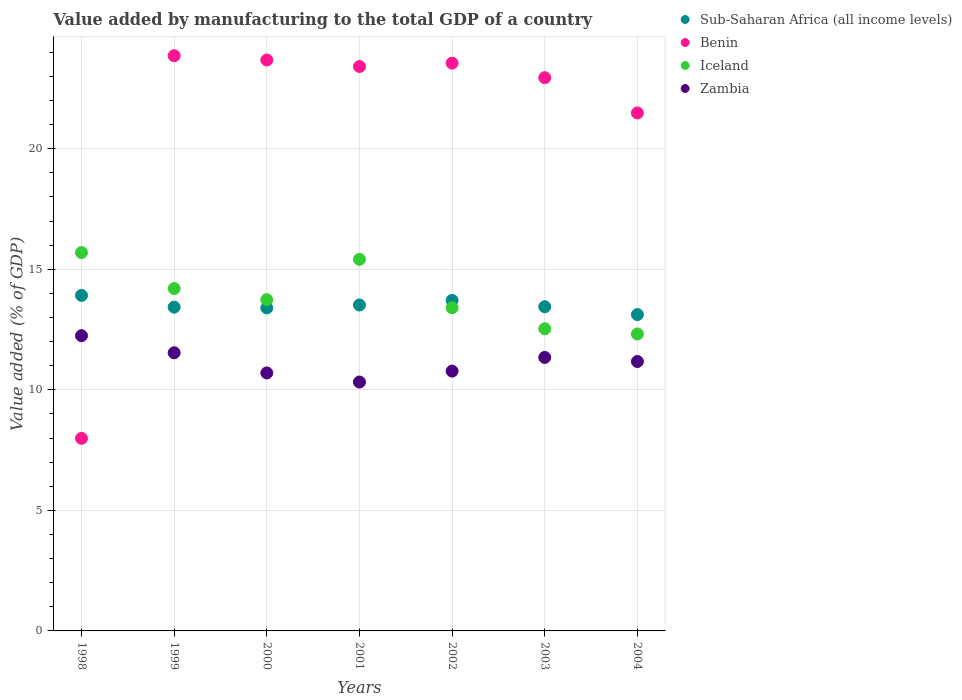Is the number of dotlines equal to the number of legend labels?
Provide a short and direct response. Yes. What is the value added by manufacturing to the total GDP in Zambia in 1998?
Your response must be concise. 12.24. Across all years, what is the maximum value added by manufacturing to the total GDP in Zambia?
Keep it short and to the point. 12.24. Across all years, what is the minimum value added by manufacturing to the total GDP in Sub-Saharan Africa (all income levels)?
Your response must be concise. 13.12. In which year was the value added by manufacturing to the total GDP in Benin maximum?
Your answer should be compact. 1999. In which year was the value added by manufacturing to the total GDP in Benin minimum?
Keep it short and to the point. 1998. What is the total value added by manufacturing to the total GDP in Benin in the graph?
Make the answer very short. 146.9. What is the difference between the value added by manufacturing to the total GDP in Sub-Saharan Africa (all income levels) in 1999 and that in 2003?
Offer a very short reply. -0.02. What is the difference between the value added by manufacturing to the total GDP in Iceland in 2003 and the value added by manufacturing to the total GDP in Zambia in 2001?
Offer a very short reply. 2.21. What is the average value added by manufacturing to the total GDP in Sub-Saharan Africa (all income levels) per year?
Ensure brevity in your answer.  13.5. In the year 2002, what is the difference between the value added by manufacturing to the total GDP in Benin and value added by manufacturing to the total GDP in Iceland?
Your response must be concise. 10.15. What is the ratio of the value added by manufacturing to the total GDP in Zambia in 1998 to that in 2004?
Offer a terse response. 1.1. What is the difference between the highest and the second highest value added by manufacturing to the total GDP in Zambia?
Offer a terse response. 0.71. What is the difference between the highest and the lowest value added by manufacturing to the total GDP in Sub-Saharan Africa (all income levels)?
Your answer should be very brief. 0.8. Is the sum of the value added by manufacturing to the total GDP in Sub-Saharan Africa (all income levels) in 2000 and 2004 greater than the maximum value added by manufacturing to the total GDP in Iceland across all years?
Offer a very short reply. Yes. Is it the case that in every year, the sum of the value added by manufacturing to the total GDP in Zambia and value added by manufacturing to the total GDP in Benin  is greater than the sum of value added by manufacturing to the total GDP in Iceland and value added by manufacturing to the total GDP in Sub-Saharan Africa (all income levels)?
Provide a succinct answer. No. Is it the case that in every year, the sum of the value added by manufacturing to the total GDP in Iceland and value added by manufacturing to the total GDP in Zambia  is greater than the value added by manufacturing to the total GDP in Sub-Saharan Africa (all income levels)?
Offer a terse response. Yes. Does the value added by manufacturing to the total GDP in Benin monotonically increase over the years?
Give a very brief answer. No. How many dotlines are there?
Keep it short and to the point. 4. How many years are there in the graph?
Give a very brief answer. 7. How many legend labels are there?
Ensure brevity in your answer.  4. What is the title of the graph?
Make the answer very short. Value added by manufacturing to the total GDP of a country. What is the label or title of the X-axis?
Make the answer very short. Years. What is the label or title of the Y-axis?
Make the answer very short. Value added (% of GDP). What is the Value added (% of GDP) of Sub-Saharan Africa (all income levels) in 1998?
Ensure brevity in your answer.  13.92. What is the Value added (% of GDP) of Benin in 1998?
Offer a very short reply. 7.99. What is the Value added (% of GDP) of Iceland in 1998?
Provide a succinct answer. 15.69. What is the Value added (% of GDP) of Zambia in 1998?
Keep it short and to the point. 12.24. What is the Value added (% of GDP) in Sub-Saharan Africa (all income levels) in 1999?
Offer a very short reply. 13.43. What is the Value added (% of GDP) of Benin in 1999?
Make the answer very short. 23.86. What is the Value added (% of GDP) of Iceland in 1999?
Make the answer very short. 14.2. What is the Value added (% of GDP) of Zambia in 1999?
Your answer should be compact. 11.54. What is the Value added (% of GDP) of Sub-Saharan Africa (all income levels) in 2000?
Provide a succinct answer. 13.4. What is the Value added (% of GDP) in Benin in 2000?
Offer a terse response. 23.68. What is the Value added (% of GDP) in Iceland in 2000?
Your answer should be compact. 13.74. What is the Value added (% of GDP) in Zambia in 2000?
Keep it short and to the point. 10.7. What is the Value added (% of GDP) in Sub-Saharan Africa (all income levels) in 2001?
Provide a short and direct response. 13.52. What is the Value added (% of GDP) in Benin in 2001?
Provide a succinct answer. 23.41. What is the Value added (% of GDP) in Iceland in 2001?
Your response must be concise. 15.41. What is the Value added (% of GDP) of Zambia in 2001?
Your answer should be compact. 10.32. What is the Value added (% of GDP) in Sub-Saharan Africa (all income levels) in 2002?
Offer a very short reply. 13.71. What is the Value added (% of GDP) of Benin in 2002?
Your answer should be compact. 23.55. What is the Value added (% of GDP) of Iceland in 2002?
Provide a succinct answer. 13.4. What is the Value added (% of GDP) in Zambia in 2002?
Offer a terse response. 10.78. What is the Value added (% of GDP) of Sub-Saharan Africa (all income levels) in 2003?
Provide a short and direct response. 13.45. What is the Value added (% of GDP) of Benin in 2003?
Keep it short and to the point. 22.94. What is the Value added (% of GDP) of Iceland in 2003?
Your answer should be very brief. 12.53. What is the Value added (% of GDP) of Zambia in 2003?
Give a very brief answer. 11.34. What is the Value added (% of GDP) of Sub-Saharan Africa (all income levels) in 2004?
Make the answer very short. 13.12. What is the Value added (% of GDP) of Benin in 2004?
Provide a succinct answer. 21.48. What is the Value added (% of GDP) of Iceland in 2004?
Provide a succinct answer. 12.31. What is the Value added (% of GDP) of Zambia in 2004?
Give a very brief answer. 11.17. Across all years, what is the maximum Value added (% of GDP) of Sub-Saharan Africa (all income levels)?
Offer a very short reply. 13.92. Across all years, what is the maximum Value added (% of GDP) of Benin?
Your answer should be very brief. 23.86. Across all years, what is the maximum Value added (% of GDP) in Iceland?
Your answer should be very brief. 15.69. Across all years, what is the maximum Value added (% of GDP) in Zambia?
Make the answer very short. 12.24. Across all years, what is the minimum Value added (% of GDP) in Sub-Saharan Africa (all income levels)?
Ensure brevity in your answer.  13.12. Across all years, what is the minimum Value added (% of GDP) of Benin?
Give a very brief answer. 7.99. Across all years, what is the minimum Value added (% of GDP) in Iceland?
Give a very brief answer. 12.31. Across all years, what is the minimum Value added (% of GDP) of Zambia?
Your answer should be very brief. 10.32. What is the total Value added (% of GDP) of Sub-Saharan Africa (all income levels) in the graph?
Your answer should be very brief. 94.53. What is the total Value added (% of GDP) of Benin in the graph?
Offer a terse response. 146.9. What is the total Value added (% of GDP) in Iceland in the graph?
Your answer should be compact. 97.29. What is the total Value added (% of GDP) in Zambia in the graph?
Provide a succinct answer. 78.09. What is the difference between the Value added (% of GDP) in Sub-Saharan Africa (all income levels) in 1998 and that in 1999?
Your answer should be very brief. 0.49. What is the difference between the Value added (% of GDP) in Benin in 1998 and that in 1999?
Your response must be concise. -15.87. What is the difference between the Value added (% of GDP) of Iceland in 1998 and that in 1999?
Offer a very short reply. 1.49. What is the difference between the Value added (% of GDP) of Zambia in 1998 and that in 1999?
Offer a terse response. 0.71. What is the difference between the Value added (% of GDP) of Sub-Saharan Africa (all income levels) in 1998 and that in 2000?
Provide a short and direct response. 0.52. What is the difference between the Value added (% of GDP) of Benin in 1998 and that in 2000?
Keep it short and to the point. -15.69. What is the difference between the Value added (% of GDP) in Iceland in 1998 and that in 2000?
Give a very brief answer. 1.95. What is the difference between the Value added (% of GDP) in Zambia in 1998 and that in 2000?
Your answer should be compact. 1.54. What is the difference between the Value added (% of GDP) of Sub-Saharan Africa (all income levels) in 1998 and that in 2001?
Make the answer very short. 0.4. What is the difference between the Value added (% of GDP) in Benin in 1998 and that in 2001?
Your answer should be very brief. -15.42. What is the difference between the Value added (% of GDP) of Iceland in 1998 and that in 2001?
Offer a very short reply. 0.28. What is the difference between the Value added (% of GDP) of Zambia in 1998 and that in 2001?
Keep it short and to the point. 1.92. What is the difference between the Value added (% of GDP) of Sub-Saharan Africa (all income levels) in 1998 and that in 2002?
Provide a succinct answer. 0.21. What is the difference between the Value added (% of GDP) in Benin in 1998 and that in 2002?
Provide a short and direct response. -15.56. What is the difference between the Value added (% of GDP) of Iceland in 1998 and that in 2002?
Ensure brevity in your answer.  2.29. What is the difference between the Value added (% of GDP) of Zambia in 1998 and that in 2002?
Provide a short and direct response. 1.47. What is the difference between the Value added (% of GDP) of Sub-Saharan Africa (all income levels) in 1998 and that in 2003?
Give a very brief answer. 0.47. What is the difference between the Value added (% of GDP) of Benin in 1998 and that in 2003?
Ensure brevity in your answer.  -14.96. What is the difference between the Value added (% of GDP) of Iceland in 1998 and that in 2003?
Give a very brief answer. 3.16. What is the difference between the Value added (% of GDP) in Zambia in 1998 and that in 2003?
Make the answer very short. 0.9. What is the difference between the Value added (% of GDP) in Sub-Saharan Africa (all income levels) in 1998 and that in 2004?
Offer a very short reply. 0.8. What is the difference between the Value added (% of GDP) of Benin in 1998 and that in 2004?
Provide a succinct answer. -13.5. What is the difference between the Value added (% of GDP) in Iceland in 1998 and that in 2004?
Offer a terse response. 3.38. What is the difference between the Value added (% of GDP) in Zambia in 1998 and that in 2004?
Offer a terse response. 1.07. What is the difference between the Value added (% of GDP) of Sub-Saharan Africa (all income levels) in 1999 and that in 2000?
Provide a succinct answer. 0.03. What is the difference between the Value added (% of GDP) in Benin in 1999 and that in 2000?
Make the answer very short. 0.18. What is the difference between the Value added (% of GDP) in Iceland in 1999 and that in 2000?
Ensure brevity in your answer.  0.46. What is the difference between the Value added (% of GDP) of Zambia in 1999 and that in 2000?
Ensure brevity in your answer.  0.84. What is the difference between the Value added (% of GDP) of Sub-Saharan Africa (all income levels) in 1999 and that in 2001?
Give a very brief answer. -0.09. What is the difference between the Value added (% of GDP) of Benin in 1999 and that in 2001?
Offer a very short reply. 0.45. What is the difference between the Value added (% of GDP) in Iceland in 1999 and that in 2001?
Offer a terse response. -1.21. What is the difference between the Value added (% of GDP) of Zambia in 1999 and that in 2001?
Offer a terse response. 1.21. What is the difference between the Value added (% of GDP) in Sub-Saharan Africa (all income levels) in 1999 and that in 2002?
Ensure brevity in your answer.  -0.28. What is the difference between the Value added (% of GDP) in Benin in 1999 and that in 2002?
Your answer should be compact. 0.31. What is the difference between the Value added (% of GDP) of Iceland in 1999 and that in 2002?
Your answer should be compact. 0.8. What is the difference between the Value added (% of GDP) of Zambia in 1999 and that in 2002?
Your response must be concise. 0.76. What is the difference between the Value added (% of GDP) of Sub-Saharan Africa (all income levels) in 1999 and that in 2003?
Offer a very short reply. -0.02. What is the difference between the Value added (% of GDP) of Benin in 1999 and that in 2003?
Keep it short and to the point. 0.91. What is the difference between the Value added (% of GDP) of Iceland in 1999 and that in 2003?
Your answer should be very brief. 1.67. What is the difference between the Value added (% of GDP) in Zambia in 1999 and that in 2003?
Keep it short and to the point. 0.19. What is the difference between the Value added (% of GDP) of Sub-Saharan Africa (all income levels) in 1999 and that in 2004?
Offer a terse response. 0.31. What is the difference between the Value added (% of GDP) of Benin in 1999 and that in 2004?
Your response must be concise. 2.37. What is the difference between the Value added (% of GDP) in Iceland in 1999 and that in 2004?
Offer a terse response. 1.88. What is the difference between the Value added (% of GDP) of Zambia in 1999 and that in 2004?
Offer a terse response. 0.36. What is the difference between the Value added (% of GDP) in Sub-Saharan Africa (all income levels) in 2000 and that in 2001?
Offer a very short reply. -0.12. What is the difference between the Value added (% of GDP) of Benin in 2000 and that in 2001?
Offer a very short reply. 0.27. What is the difference between the Value added (% of GDP) of Iceland in 2000 and that in 2001?
Offer a very short reply. -1.67. What is the difference between the Value added (% of GDP) of Zambia in 2000 and that in 2001?
Provide a short and direct response. 0.38. What is the difference between the Value added (% of GDP) of Sub-Saharan Africa (all income levels) in 2000 and that in 2002?
Keep it short and to the point. -0.31. What is the difference between the Value added (% of GDP) in Benin in 2000 and that in 2002?
Your response must be concise. 0.13. What is the difference between the Value added (% of GDP) in Iceland in 2000 and that in 2002?
Ensure brevity in your answer.  0.34. What is the difference between the Value added (% of GDP) in Zambia in 2000 and that in 2002?
Provide a short and direct response. -0.08. What is the difference between the Value added (% of GDP) of Sub-Saharan Africa (all income levels) in 2000 and that in 2003?
Provide a succinct answer. -0.05. What is the difference between the Value added (% of GDP) of Benin in 2000 and that in 2003?
Offer a terse response. 0.73. What is the difference between the Value added (% of GDP) of Iceland in 2000 and that in 2003?
Keep it short and to the point. 1.21. What is the difference between the Value added (% of GDP) of Zambia in 2000 and that in 2003?
Your response must be concise. -0.64. What is the difference between the Value added (% of GDP) of Sub-Saharan Africa (all income levels) in 2000 and that in 2004?
Ensure brevity in your answer.  0.28. What is the difference between the Value added (% of GDP) in Benin in 2000 and that in 2004?
Offer a terse response. 2.19. What is the difference between the Value added (% of GDP) in Iceland in 2000 and that in 2004?
Keep it short and to the point. 1.42. What is the difference between the Value added (% of GDP) in Zambia in 2000 and that in 2004?
Keep it short and to the point. -0.47. What is the difference between the Value added (% of GDP) of Sub-Saharan Africa (all income levels) in 2001 and that in 2002?
Your answer should be compact. -0.19. What is the difference between the Value added (% of GDP) in Benin in 2001 and that in 2002?
Offer a terse response. -0.14. What is the difference between the Value added (% of GDP) of Iceland in 2001 and that in 2002?
Your answer should be very brief. 2.01. What is the difference between the Value added (% of GDP) of Zambia in 2001 and that in 2002?
Provide a short and direct response. -0.45. What is the difference between the Value added (% of GDP) in Sub-Saharan Africa (all income levels) in 2001 and that in 2003?
Provide a succinct answer. 0.07. What is the difference between the Value added (% of GDP) in Benin in 2001 and that in 2003?
Offer a terse response. 0.46. What is the difference between the Value added (% of GDP) in Iceland in 2001 and that in 2003?
Your answer should be very brief. 2.88. What is the difference between the Value added (% of GDP) in Zambia in 2001 and that in 2003?
Keep it short and to the point. -1.02. What is the difference between the Value added (% of GDP) of Sub-Saharan Africa (all income levels) in 2001 and that in 2004?
Make the answer very short. 0.4. What is the difference between the Value added (% of GDP) of Benin in 2001 and that in 2004?
Your answer should be very brief. 1.92. What is the difference between the Value added (% of GDP) in Iceland in 2001 and that in 2004?
Your answer should be compact. 3.1. What is the difference between the Value added (% of GDP) of Zambia in 2001 and that in 2004?
Provide a succinct answer. -0.85. What is the difference between the Value added (% of GDP) in Sub-Saharan Africa (all income levels) in 2002 and that in 2003?
Offer a very short reply. 0.26. What is the difference between the Value added (% of GDP) in Benin in 2002 and that in 2003?
Your answer should be compact. 0.6. What is the difference between the Value added (% of GDP) in Iceland in 2002 and that in 2003?
Provide a succinct answer. 0.87. What is the difference between the Value added (% of GDP) in Zambia in 2002 and that in 2003?
Make the answer very short. -0.57. What is the difference between the Value added (% of GDP) in Sub-Saharan Africa (all income levels) in 2002 and that in 2004?
Keep it short and to the point. 0.59. What is the difference between the Value added (% of GDP) in Benin in 2002 and that in 2004?
Your answer should be very brief. 2.06. What is the difference between the Value added (% of GDP) of Iceland in 2002 and that in 2004?
Give a very brief answer. 1.09. What is the difference between the Value added (% of GDP) of Zambia in 2002 and that in 2004?
Ensure brevity in your answer.  -0.4. What is the difference between the Value added (% of GDP) in Sub-Saharan Africa (all income levels) in 2003 and that in 2004?
Keep it short and to the point. 0.33. What is the difference between the Value added (% of GDP) in Benin in 2003 and that in 2004?
Make the answer very short. 1.46. What is the difference between the Value added (% of GDP) in Iceland in 2003 and that in 2004?
Provide a succinct answer. 0.22. What is the difference between the Value added (% of GDP) of Zambia in 2003 and that in 2004?
Provide a succinct answer. 0.17. What is the difference between the Value added (% of GDP) of Sub-Saharan Africa (all income levels) in 1998 and the Value added (% of GDP) of Benin in 1999?
Provide a short and direct response. -9.94. What is the difference between the Value added (% of GDP) of Sub-Saharan Africa (all income levels) in 1998 and the Value added (% of GDP) of Iceland in 1999?
Keep it short and to the point. -0.28. What is the difference between the Value added (% of GDP) in Sub-Saharan Africa (all income levels) in 1998 and the Value added (% of GDP) in Zambia in 1999?
Your response must be concise. 2.38. What is the difference between the Value added (% of GDP) of Benin in 1998 and the Value added (% of GDP) of Iceland in 1999?
Provide a short and direct response. -6.21. What is the difference between the Value added (% of GDP) of Benin in 1998 and the Value added (% of GDP) of Zambia in 1999?
Provide a short and direct response. -3.55. What is the difference between the Value added (% of GDP) in Iceland in 1998 and the Value added (% of GDP) in Zambia in 1999?
Offer a very short reply. 4.15. What is the difference between the Value added (% of GDP) of Sub-Saharan Africa (all income levels) in 1998 and the Value added (% of GDP) of Benin in 2000?
Your answer should be very brief. -9.76. What is the difference between the Value added (% of GDP) in Sub-Saharan Africa (all income levels) in 1998 and the Value added (% of GDP) in Iceland in 2000?
Provide a succinct answer. 0.18. What is the difference between the Value added (% of GDP) of Sub-Saharan Africa (all income levels) in 1998 and the Value added (% of GDP) of Zambia in 2000?
Offer a very short reply. 3.22. What is the difference between the Value added (% of GDP) of Benin in 1998 and the Value added (% of GDP) of Iceland in 2000?
Your response must be concise. -5.75. What is the difference between the Value added (% of GDP) in Benin in 1998 and the Value added (% of GDP) in Zambia in 2000?
Ensure brevity in your answer.  -2.71. What is the difference between the Value added (% of GDP) of Iceland in 1998 and the Value added (% of GDP) of Zambia in 2000?
Make the answer very short. 4.99. What is the difference between the Value added (% of GDP) of Sub-Saharan Africa (all income levels) in 1998 and the Value added (% of GDP) of Benin in 2001?
Offer a terse response. -9.49. What is the difference between the Value added (% of GDP) of Sub-Saharan Africa (all income levels) in 1998 and the Value added (% of GDP) of Iceland in 2001?
Ensure brevity in your answer.  -1.5. What is the difference between the Value added (% of GDP) in Sub-Saharan Africa (all income levels) in 1998 and the Value added (% of GDP) in Zambia in 2001?
Give a very brief answer. 3.59. What is the difference between the Value added (% of GDP) of Benin in 1998 and the Value added (% of GDP) of Iceland in 2001?
Ensure brevity in your answer.  -7.42. What is the difference between the Value added (% of GDP) of Benin in 1998 and the Value added (% of GDP) of Zambia in 2001?
Make the answer very short. -2.33. What is the difference between the Value added (% of GDP) of Iceland in 1998 and the Value added (% of GDP) of Zambia in 2001?
Your answer should be very brief. 5.37. What is the difference between the Value added (% of GDP) in Sub-Saharan Africa (all income levels) in 1998 and the Value added (% of GDP) in Benin in 2002?
Provide a short and direct response. -9.63. What is the difference between the Value added (% of GDP) in Sub-Saharan Africa (all income levels) in 1998 and the Value added (% of GDP) in Iceland in 2002?
Give a very brief answer. 0.51. What is the difference between the Value added (% of GDP) in Sub-Saharan Africa (all income levels) in 1998 and the Value added (% of GDP) in Zambia in 2002?
Offer a terse response. 3.14. What is the difference between the Value added (% of GDP) in Benin in 1998 and the Value added (% of GDP) in Iceland in 2002?
Ensure brevity in your answer.  -5.42. What is the difference between the Value added (% of GDP) in Benin in 1998 and the Value added (% of GDP) in Zambia in 2002?
Ensure brevity in your answer.  -2.79. What is the difference between the Value added (% of GDP) of Iceland in 1998 and the Value added (% of GDP) of Zambia in 2002?
Your answer should be very brief. 4.92. What is the difference between the Value added (% of GDP) in Sub-Saharan Africa (all income levels) in 1998 and the Value added (% of GDP) in Benin in 2003?
Provide a short and direct response. -9.03. What is the difference between the Value added (% of GDP) in Sub-Saharan Africa (all income levels) in 1998 and the Value added (% of GDP) in Iceland in 2003?
Provide a succinct answer. 1.38. What is the difference between the Value added (% of GDP) in Sub-Saharan Africa (all income levels) in 1998 and the Value added (% of GDP) in Zambia in 2003?
Make the answer very short. 2.57. What is the difference between the Value added (% of GDP) of Benin in 1998 and the Value added (% of GDP) of Iceland in 2003?
Your answer should be very brief. -4.55. What is the difference between the Value added (% of GDP) in Benin in 1998 and the Value added (% of GDP) in Zambia in 2003?
Provide a succinct answer. -3.36. What is the difference between the Value added (% of GDP) in Iceland in 1998 and the Value added (% of GDP) in Zambia in 2003?
Ensure brevity in your answer.  4.35. What is the difference between the Value added (% of GDP) in Sub-Saharan Africa (all income levels) in 1998 and the Value added (% of GDP) in Benin in 2004?
Provide a short and direct response. -7.57. What is the difference between the Value added (% of GDP) in Sub-Saharan Africa (all income levels) in 1998 and the Value added (% of GDP) in Iceland in 2004?
Make the answer very short. 1.6. What is the difference between the Value added (% of GDP) of Sub-Saharan Africa (all income levels) in 1998 and the Value added (% of GDP) of Zambia in 2004?
Provide a succinct answer. 2.74. What is the difference between the Value added (% of GDP) of Benin in 1998 and the Value added (% of GDP) of Iceland in 2004?
Offer a terse response. -4.33. What is the difference between the Value added (% of GDP) in Benin in 1998 and the Value added (% of GDP) in Zambia in 2004?
Provide a short and direct response. -3.19. What is the difference between the Value added (% of GDP) of Iceland in 1998 and the Value added (% of GDP) of Zambia in 2004?
Your response must be concise. 4.52. What is the difference between the Value added (% of GDP) in Sub-Saharan Africa (all income levels) in 1999 and the Value added (% of GDP) in Benin in 2000?
Ensure brevity in your answer.  -10.25. What is the difference between the Value added (% of GDP) in Sub-Saharan Africa (all income levels) in 1999 and the Value added (% of GDP) in Iceland in 2000?
Provide a short and direct response. -0.31. What is the difference between the Value added (% of GDP) in Sub-Saharan Africa (all income levels) in 1999 and the Value added (% of GDP) in Zambia in 2000?
Your response must be concise. 2.73. What is the difference between the Value added (% of GDP) of Benin in 1999 and the Value added (% of GDP) of Iceland in 2000?
Your response must be concise. 10.12. What is the difference between the Value added (% of GDP) of Benin in 1999 and the Value added (% of GDP) of Zambia in 2000?
Your answer should be compact. 13.16. What is the difference between the Value added (% of GDP) of Iceland in 1999 and the Value added (% of GDP) of Zambia in 2000?
Keep it short and to the point. 3.5. What is the difference between the Value added (% of GDP) of Sub-Saharan Africa (all income levels) in 1999 and the Value added (% of GDP) of Benin in 2001?
Keep it short and to the point. -9.98. What is the difference between the Value added (% of GDP) in Sub-Saharan Africa (all income levels) in 1999 and the Value added (% of GDP) in Iceland in 2001?
Make the answer very short. -1.98. What is the difference between the Value added (% of GDP) of Sub-Saharan Africa (all income levels) in 1999 and the Value added (% of GDP) of Zambia in 2001?
Your response must be concise. 3.11. What is the difference between the Value added (% of GDP) in Benin in 1999 and the Value added (% of GDP) in Iceland in 2001?
Keep it short and to the point. 8.45. What is the difference between the Value added (% of GDP) of Benin in 1999 and the Value added (% of GDP) of Zambia in 2001?
Your response must be concise. 13.53. What is the difference between the Value added (% of GDP) in Iceland in 1999 and the Value added (% of GDP) in Zambia in 2001?
Give a very brief answer. 3.88. What is the difference between the Value added (% of GDP) of Sub-Saharan Africa (all income levels) in 1999 and the Value added (% of GDP) of Benin in 2002?
Make the answer very short. -10.12. What is the difference between the Value added (% of GDP) of Sub-Saharan Africa (all income levels) in 1999 and the Value added (% of GDP) of Iceland in 2002?
Your answer should be compact. 0.03. What is the difference between the Value added (% of GDP) of Sub-Saharan Africa (all income levels) in 1999 and the Value added (% of GDP) of Zambia in 2002?
Provide a short and direct response. 2.65. What is the difference between the Value added (% of GDP) in Benin in 1999 and the Value added (% of GDP) in Iceland in 2002?
Offer a terse response. 10.45. What is the difference between the Value added (% of GDP) in Benin in 1999 and the Value added (% of GDP) in Zambia in 2002?
Your answer should be compact. 13.08. What is the difference between the Value added (% of GDP) of Iceland in 1999 and the Value added (% of GDP) of Zambia in 2002?
Your answer should be very brief. 3.42. What is the difference between the Value added (% of GDP) of Sub-Saharan Africa (all income levels) in 1999 and the Value added (% of GDP) of Benin in 2003?
Your response must be concise. -9.52. What is the difference between the Value added (% of GDP) of Sub-Saharan Africa (all income levels) in 1999 and the Value added (% of GDP) of Iceland in 2003?
Keep it short and to the point. 0.9. What is the difference between the Value added (% of GDP) of Sub-Saharan Africa (all income levels) in 1999 and the Value added (% of GDP) of Zambia in 2003?
Your answer should be compact. 2.09. What is the difference between the Value added (% of GDP) of Benin in 1999 and the Value added (% of GDP) of Iceland in 2003?
Offer a terse response. 11.32. What is the difference between the Value added (% of GDP) of Benin in 1999 and the Value added (% of GDP) of Zambia in 2003?
Offer a terse response. 12.51. What is the difference between the Value added (% of GDP) of Iceland in 1999 and the Value added (% of GDP) of Zambia in 2003?
Your response must be concise. 2.86. What is the difference between the Value added (% of GDP) in Sub-Saharan Africa (all income levels) in 1999 and the Value added (% of GDP) in Benin in 2004?
Make the answer very short. -8.05. What is the difference between the Value added (% of GDP) in Sub-Saharan Africa (all income levels) in 1999 and the Value added (% of GDP) in Iceland in 2004?
Give a very brief answer. 1.11. What is the difference between the Value added (% of GDP) in Sub-Saharan Africa (all income levels) in 1999 and the Value added (% of GDP) in Zambia in 2004?
Keep it short and to the point. 2.26. What is the difference between the Value added (% of GDP) in Benin in 1999 and the Value added (% of GDP) in Iceland in 2004?
Provide a succinct answer. 11.54. What is the difference between the Value added (% of GDP) in Benin in 1999 and the Value added (% of GDP) in Zambia in 2004?
Make the answer very short. 12.68. What is the difference between the Value added (% of GDP) of Iceland in 1999 and the Value added (% of GDP) of Zambia in 2004?
Ensure brevity in your answer.  3.03. What is the difference between the Value added (% of GDP) in Sub-Saharan Africa (all income levels) in 2000 and the Value added (% of GDP) in Benin in 2001?
Provide a short and direct response. -10.01. What is the difference between the Value added (% of GDP) of Sub-Saharan Africa (all income levels) in 2000 and the Value added (% of GDP) of Iceland in 2001?
Keep it short and to the point. -2.01. What is the difference between the Value added (% of GDP) in Sub-Saharan Africa (all income levels) in 2000 and the Value added (% of GDP) in Zambia in 2001?
Make the answer very short. 3.07. What is the difference between the Value added (% of GDP) of Benin in 2000 and the Value added (% of GDP) of Iceland in 2001?
Offer a very short reply. 8.27. What is the difference between the Value added (% of GDP) in Benin in 2000 and the Value added (% of GDP) in Zambia in 2001?
Provide a succinct answer. 13.36. What is the difference between the Value added (% of GDP) in Iceland in 2000 and the Value added (% of GDP) in Zambia in 2001?
Your answer should be compact. 3.42. What is the difference between the Value added (% of GDP) of Sub-Saharan Africa (all income levels) in 2000 and the Value added (% of GDP) of Benin in 2002?
Keep it short and to the point. -10.15. What is the difference between the Value added (% of GDP) in Sub-Saharan Africa (all income levels) in 2000 and the Value added (% of GDP) in Iceland in 2002?
Your answer should be very brief. -0.01. What is the difference between the Value added (% of GDP) in Sub-Saharan Africa (all income levels) in 2000 and the Value added (% of GDP) in Zambia in 2002?
Offer a very short reply. 2.62. What is the difference between the Value added (% of GDP) in Benin in 2000 and the Value added (% of GDP) in Iceland in 2002?
Your answer should be compact. 10.28. What is the difference between the Value added (% of GDP) of Benin in 2000 and the Value added (% of GDP) of Zambia in 2002?
Ensure brevity in your answer.  12.9. What is the difference between the Value added (% of GDP) in Iceland in 2000 and the Value added (% of GDP) in Zambia in 2002?
Ensure brevity in your answer.  2.96. What is the difference between the Value added (% of GDP) in Sub-Saharan Africa (all income levels) in 2000 and the Value added (% of GDP) in Benin in 2003?
Provide a succinct answer. -9.55. What is the difference between the Value added (% of GDP) of Sub-Saharan Africa (all income levels) in 2000 and the Value added (% of GDP) of Iceland in 2003?
Your answer should be compact. 0.86. What is the difference between the Value added (% of GDP) of Sub-Saharan Africa (all income levels) in 2000 and the Value added (% of GDP) of Zambia in 2003?
Your response must be concise. 2.05. What is the difference between the Value added (% of GDP) of Benin in 2000 and the Value added (% of GDP) of Iceland in 2003?
Offer a very short reply. 11.15. What is the difference between the Value added (% of GDP) in Benin in 2000 and the Value added (% of GDP) in Zambia in 2003?
Make the answer very short. 12.34. What is the difference between the Value added (% of GDP) of Iceland in 2000 and the Value added (% of GDP) of Zambia in 2003?
Offer a terse response. 2.4. What is the difference between the Value added (% of GDP) of Sub-Saharan Africa (all income levels) in 2000 and the Value added (% of GDP) of Benin in 2004?
Keep it short and to the point. -8.09. What is the difference between the Value added (% of GDP) of Sub-Saharan Africa (all income levels) in 2000 and the Value added (% of GDP) of Iceland in 2004?
Ensure brevity in your answer.  1.08. What is the difference between the Value added (% of GDP) of Sub-Saharan Africa (all income levels) in 2000 and the Value added (% of GDP) of Zambia in 2004?
Provide a succinct answer. 2.22. What is the difference between the Value added (% of GDP) of Benin in 2000 and the Value added (% of GDP) of Iceland in 2004?
Keep it short and to the point. 11.36. What is the difference between the Value added (% of GDP) in Benin in 2000 and the Value added (% of GDP) in Zambia in 2004?
Your answer should be very brief. 12.51. What is the difference between the Value added (% of GDP) of Iceland in 2000 and the Value added (% of GDP) of Zambia in 2004?
Your answer should be compact. 2.57. What is the difference between the Value added (% of GDP) of Sub-Saharan Africa (all income levels) in 2001 and the Value added (% of GDP) of Benin in 2002?
Offer a terse response. -10.03. What is the difference between the Value added (% of GDP) in Sub-Saharan Africa (all income levels) in 2001 and the Value added (% of GDP) in Iceland in 2002?
Give a very brief answer. 0.12. What is the difference between the Value added (% of GDP) of Sub-Saharan Africa (all income levels) in 2001 and the Value added (% of GDP) of Zambia in 2002?
Your answer should be compact. 2.74. What is the difference between the Value added (% of GDP) in Benin in 2001 and the Value added (% of GDP) in Iceland in 2002?
Provide a short and direct response. 10.01. What is the difference between the Value added (% of GDP) in Benin in 2001 and the Value added (% of GDP) in Zambia in 2002?
Keep it short and to the point. 12.63. What is the difference between the Value added (% of GDP) in Iceland in 2001 and the Value added (% of GDP) in Zambia in 2002?
Offer a terse response. 4.64. What is the difference between the Value added (% of GDP) of Sub-Saharan Africa (all income levels) in 2001 and the Value added (% of GDP) of Benin in 2003?
Provide a succinct answer. -9.43. What is the difference between the Value added (% of GDP) of Sub-Saharan Africa (all income levels) in 2001 and the Value added (% of GDP) of Iceland in 2003?
Keep it short and to the point. 0.99. What is the difference between the Value added (% of GDP) in Sub-Saharan Africa (all income levels) in 2001 and the Value added (% of GDP) in Zambia in 2003?
Keep it short and to the point. 2.18. What is the difference between the Value added (% of GDP) of Benin in 2001 and the Value added (% of GDP) of Iceland in 2003?
Your response must be concise. 10.88. What is the difference between the Value added (% of GDP) of Benin in 2001 and the Value added (% of GDP) of Zambia in 2003?
Provide a short and direct response. 12.07. What is the difference between the Value added (% of GDP) of Iceland in 2001 and the Value added (% of GDP) of Zambia in 2003?
Give a very brief answer. 4.07. What is the difference between the Value added (% of GDP) of Sub-Saharan Africa (all income levels) in 2001 and the Value added (% of GDP) of Benin in 2004?
Provide a short and direct response. -7.97. What is the difference between the Value added (% of GDP) of Sub-Saharan Africa (all income levels) in 2001 and the Value added (% of GDP) of Iceland in 2004?
Ensure brevity in your answer.  1.2. What is the difference between the Value added (% of GDP) of Sub-Saharan Africa (all income levels) in 2001 and the Value added (% of GDP) of Zambia in 2004?
Your answer should be very brief. 2.35. What is the difference between the Value added (% of GDP) in Benin in 2001 and the Value added (% of GDP) in Iceland in 2004?
Give a very brief answer. 11.09. What is the difference between the Value added (% of GDP) in Benin in 2001 and the Value added (% of GDP) in Zambia in 2004?
Your response must be concise. 12.24. What is the difference between the Value added (% of GDP) of Iceland in 2001 and the Value added (% of GDP) of Zambia in 2004?
Provide a succinct answer. 4.24. What is the difference between the Value added (% of GDP) in Sub-Saharan Africa (all income levels) in 2002 and the Value added (% of GDP) in Benin in 2003?
Provide a short and direct response. -9.24. What is the difference between the Value added (% of GDP) of Sub-Saharan Africa (all income levels) in 2002 and the Value added (% of GDP) of Iceland in 2003?
Your answer should be very brief. 1.17. What is the difference between the Value added (% of GDP) in Sub-Saharan Africa (all income levels) in 2002 and the Value added (% of GDP) in Zambia in 2003?
Ensure brevity in your answer.  2.36. What is the difference between the Value added (% of GDP) in Benin in 2002 and the Value added (% of GDP) in Iceland in 2003?
Your answer should be compact. 11.02. What is the difference between the Value added (% of GDP) of Benin in 2002 and the Value added (% of GDP) of Zambia in 2003?
Your answer should be compact. 12.21. What is the difference between the Value added (% of GDP) of Iceland in 2002 and the Value added (% of GDP) of Zambia in 2003?
Provide a succinct answer. 2.06. What is the difference between the Value added (% of GDP) of Sub-Saharan Africa (all income levels) in 2002 and the Value added (% of GDP) of Benin in 2004?
Your answer should be very brief. -7.78. What is the difference between the Value added (% of GDP) of Sub-Saharan Africa (all income levels) in 2002 and the Value added (% of GDP) of Iceland in 2004?
Provide a short and direct response. 1.39. What is the difference between the Value added (% of GDP) of Sub-Saharan Africa (all income levels) in 2002 and the Value added (% of GDP) of Zambia in 2004?
Your answer should be compact. 2.53. What is the difference between the Value added (% of GDP) of Benin in 2002 and the Value added (% of GDP) of Iceland in 2004?
Make the answer very short. 11.23. What is the difference between the Value added (% of GDP) of Benin in 2002 and the Value added (% of GDP) of Zambia in 2004?
Keep it short and to the point. 12.38. What is the difference between the Value added (% of GDP) in Iceland in 2002 and the Value added (% of GDP) in Zambia in 2004?
Offer a very short reply. 2.23. What is the difference between the Value added (% of GDP) of Sub-Saharan Africa (all income levels) in 2003 and the Value added (% of GDP) of Benin in 2004?
Make the answer very short. -8.04. What is the difference between the Value added (% of GDP) of Sub-Saharan Africa (all income levels) in 2003 and the Value added (% of GDP) of Iceland in 2004?
Ensure brevity in your answer.  1.13. What is the difference between the Value added (% of GDP) of Sub-Saharan Africa (all income levels) in 2003 and the Value added (% of GDP) of Zambia in 2004?
Offer a very short reply. 2.27. What is the difference between the Value added (% of GDP) in Benin in 2003 and the Value added (% of GDP) in Iceland in 2004?
Provide a succinct answer. 10.63. What is the difference between the Value added (% of GDP) in Benin in 2003 and the Value added (% of GDP) in Zambia in 2004?
Offer a terse response. 11.77. What is the difference between the Value added (% of GDP) in Iceland in 2003 and the Value added (% of GDP) in Zambia in 2004?
Offer a very short reply. 1.36. What is the average Value added (% of GDP) of Sub-Saharan Africa (all income levels) per year?
Ensure brevity in your answer.  13.5. What is the average Value added (% of GDP) in Benin per year?
Your answer should be very brief. 20.99. What is the average Value added (% of GDP) in Iceland per year?
Offer a terse response. 13.9. What is the average Value added (% of GDP) of Zambia per year?
Provide a short and direct response. 11.16. In the year 1998, what is the difference between the Value added (% of GDP) in Sub-Saharan Africa (all income levels) and Value added (% of GDP) in Benin?
Offer a very short reply. 5.93. In the year 1998, what is the difference between the Value added (% of GDP) of Sub-Saharan Africa (all income levels) and Value added (% of GDP) of Iceland?
Your answer should be compact. -1.78. In the year 1998, what is the difference between the Value added (% of GDP) of Sub-Saharan Africa (all income levels) and Value added (% of GDP) of Zambia?
Ensure brevity in your answer.  1.67. In the year 1998, what is the difference between the Value added (% of GDP) of Benin and Value added (% of GDP) of Iceland?
Provide a succinct answer. -7.7. In the year 1998, what is the difference between the Value added (% of GDP) in Benin and Value added (% of GDP) in Zambia?
Keep it short and to the point. -4.26. In the year 1998, what is the difference between the Value added (% of GDP) in Iceland and Value added (% of GDP) in Zambia?
Offer a terse response. 3.45. In the year 1999, what is the difference between the Value added (% of GDP) in Sub-Saharan Africa (all income levels) and Value added (% of GDP) in Benin?
Offer a very short reply. -10.43. In the year 1999, what is the difference between the Value added (% of GDP) of Sub-Saharan Africa (all income levels) and Value added (% of GDP) of Iceland?
Your response must be concise. -0.77. In the year 1999, what is the difference between the Value added (% of GDP) in Sub-Saharan Africa (all income levels) and Value added (% of GDP) in Zambia?
Your answer should be very brief. 1.89. In the year 1999, what is the difference between the Value added (% of GDP) in Benin and Value added (% of GDP) in Iceland?
Your answer should be compact. 9.66. In the year 1999, what is the difference between the Value added (% of GDP) in Benin and Value added (% of GDP) in Zambia?
Provide a succinct answer. 12.32. In the year 1999, what is the difference between the Value added (% of GDP) of Iceland and Value added (% of GDP) of Zambia?
Offer a terse response. 2.66. In the year 2000, what is the difference between the Value added (% of GDP) in Sub-Saharan Africa (all income levels) and Value added (% of GDP) in Benin?
Provide a short and direct response. -10.28. In the year 2000, what is the difference between the Value added (% of GDP) of Sub-Saharan Africa (all income levels) and Value added (% of GDP) of Iceland?
Your answer should be very brief. -0.34. In the year 2000, what is the difference between the Value added (% of GDP) of Sub-Saharan Africa (all income levels) and Value added (% of GDP) of Zambia?
Offer a terse response. 2.7. In the year 2000, what is the difference between the Value added (% of GDP) of Benin and Value added (% of GDP) of Iceland?
Provide a succinct answer. 9.94. In the year 2000, what is the difference between the Value added (% of GDP) of Benin and Value added (% of GDP) of Zambia?
Offer a terse response. 12.98. In the year 2000, what is the difference between the Value added (% of GDP) of Iceland and Value added (% of GDP) of Zambia?
Your answer should be compact. 3.04. In the year 2001, what is the difference between the Value added (% of GDP) of Sub-Saharan Africa (all income levels) and Value added (% of GDP) of Benin?
Offer a very short reply. -9.89. In the year 2001, what is the difference between the Value added (% of GDP) of Sub-Saharan Africa (all income levels) and Value added (% of GDP) of Iceland?
Keep it short and to the point. -1.89. In the year 2001, what is the difference between the Value added (% of GDP) in Sub-Saharan Africa (all income levels) and Value added (% of GDP) in Zambia?
Your answer should be very brief. 3.2. In the year 2001, what is the difference between the Value added (% of GDP) of Benin and Value added (% of GDP) of Iceland?
Make the answer very short. 8. In the year 2001, what is the difference between the Value added (% of GDP) of Benin and Value added (% of GDP) of Zambia?
Your answer should be compact. 13.09. In the year 2001, what is the difference between the Value added (% of GDP) in Iceland and Value added (% of GDP) in Zambia?
Give a very brief answer. 5.09. In the year 2002, what is the difference between the Value added (% of GDP) in Sub-Saharan Africa (all income levels) and Value added (% of GDP) in Benin?
Provide a succinct answer. -9.84. In the year 2002, what is the difference between the Value added (% of GDP) of Sub-Saharan Africa (all income levels) and Value added (% of GDP) of Iceland?
Keep it short and to the point. 0.3. In the year 2002, what is the difference between the Value added (% of GDP) in Sub-Saharan Africa (all income levels) and Value added (% of GDP) in Zambia?
Your answer should be very brief. 2.93. In the year 2002, what is the difference between the Value added (% of GDP) of Benin and Value added (% of GDP) of Iceland?
Give a very brief answer. 10.15. In the year 2002, what is the difference between the Value added (% of GDP) in Benin and Value added (% of GDP) in Zambia?
Keep it short and to the point. 12.77. In the year 2002, what is the difference between the Value added (% of GDP) in Iceland and Value added (% of GDP) in Zambia?
Your response must be concise. 2.63. In the year 2003, what is the difference between the Value added (% of GDP) in Sub-Saharan Africa (all income levels) and Value added (% of GDP) in Benin?
Provide a succinct answer. -9.5. In the year 2003, what is the difference between the Value added (% of GDP) in Sub-Saharan Africa (all income levels) and Value added (% of GDP) in Iceland?
Provide a succinct answer. 0.91. In the year 2003, what is the difference between the Value added (% of GDP) of Sub-Saharan Africa (all income levels) and Value added (% of GDP) of Zambia?
Provide a succinct answer. 2.1. In the year 2003, what is the difference between the Value added (% of GDP) of Benin and Value added (% of GDP) of Iceland?
Offer a very short reply. 10.41. In the year 2003, what is the difference between the Value added (% of GDP) in Benin and Value added (% of GDP) in Zambia?
Provide a short and direct response. 11.6. In the year 2003, what is the difference between the Value added (% of GDP) in Iceland and Value added (% of GDP) in Zambia?
Ensure brevity in your answer.  1.19. In the year 2004, what is the difference between the Value added (% of GDP) in Sub-Saharan Africa (all income levels) and Value added (% of GDP) in Benin?
Provide a short and direct response. -8.36. In the year 2004, what is the difference between the Value added (% of GDP) of Sub-Saharan Africa (all income levels) and Value added (% of GDP) of Iceland?
Offer a terse response. 0.81. In the year 2004, what is the difference between the Value added (% of GDP) of Sub-Saharan Africa (all income levels) and Value added (% of GDP) of Zambia?
Provide a short and direct response. 1.95. In the year 2004, what is the difference between the Value added (% of GDP) in Benin and Value added (% of GDP) in Iceland?
Offer a very short reply. 9.17. In the year 2004, what is the difference between the Value added (% of GDP) of Benin and Value added (% of GDP) of Zambia?
Make the answer very short. 10.31. In the year 2004, what is the difference between the Value added (% of GDP) of Iceland and Value added (% of GDP) of Zambia?
Keep it short and to the point. 1.14. What is the ratio of the Value added (% of GDP) in Sub-Saharan Africa (all income levels) in 1998 to that in 1999?
Your response must be concise. 1.04. What is the ratio of the Value added (% of GDP) of Benin in 1998 to that in 1999?
Provide a short and direct response. 0.33. What is the ratio of the Value added (% of GDP) in Iceland in 1998 to that in 1999?
Provide a short and direct response. 1.11. What is the ratio of the Value added (% of GDP) of Zambia in 1998 to that in 1999?
Ensure brevity in your answer.  1.06. What is the ratio of the Value added (% of GDP) in Sub-Saharan Africa (all income levels) in 1998 to that in 2000?
Your answer should be compact. 1.04. What is the ratio of the Value added (% of GDP) of Benin in 1998 to that in 2000?
Keep it short and to the point. 0.34. What is the ratio of the Value added (% of GDP) in Iceland in 1998 to that in 2000?
Make the answer very short. 1.14. What is the ratio of the Value added (% of GDP) of Zambia in 1998 to that in 2000?
Offer a terse response. 1.14. What is the ratio of the Value added (% of GDP) in Sub-Saharan Africa (all income levels) in 1998 to that in 2001?
Provide a succinct answer. 1.03. What is the ratio of the Value added (% of GDP) in Benin in 1998 to that in 2001?
Make the answer very short. 0.34. What is the ratio of the Value added (% of GDP) in Iceland in 1998 to that in 2001?
Your answer should be compact. 1.02. What is the ratio of the Value added (% of GDP) in Zambia in 1998 to that in 2001?
Your answer should be compact. 1.19. What is the ratio of the Value added (% of GDP) in Sub-Saharan Africa (all income levels) in 1998 to that in 2002?
Your answer should be very brief. 1.02. What is the ratio of the Value added (% of GDP) in Benin in 1998 to that in 2002?
Offer a terse response. 0.34. What is the ratio of the Value added (% of GDP) in Iceland in 1998 to that in 2002?
Provide a succinct answer. 1.17. What is the ratio of the Value added (% of GDP) of Zambia in 1998 to that in 2002?
Provide a succinct answer. 1.14. What is the ratio of the Value added (% of GDP) in Sub-Saharan Africa (all income levels) in 1998 to that in 2003?
Keep it short and to the point. 1.03. What is the ratio of the Value added (% of GDP) in Benin in 1998 to that in 2003?
Ensure brevity in your answer.  0.35. What is the ratio of the Value added (% of GDP) of Iceland in 1998 to that in 2003?
Your answer should be very brief. 1.25. What is the ratio of the Value added (% of GDP) in Zambia in 1998 to that in 2003?
Your answer should be very brief. 1.08. What is the ratio of the Value added (% of GDP) of Sub-Saharan Africa (all income levels) in 1998 to that in 2004?
Provide a succinct answer. 1.06. What is the ratio of the Value added (% of GDP) of Benin in 1998 to that in 2004?
Give a very brief answer. 0.37. What is the ratio of the Value added (% of GDP) in Iceland in 1998 to that in 2004?
Offer a terse response. 1.27. What is the ratio of the Value added (% of GDP) of Zambia in 1998 to that in 2004?
Make the answer very short. 1.1. What is the ratio of the Value added (% of GDP) of Sub-Saharan Africa (all income levels) in 1999 to that in 2000?
Provide a succinct answer. 1. What is the ratio of the Value added (% of GDP) in Benin in 1999 to that in 2000?
Provide a succinct answer. 1.01. What is the ratio of the Value added (% of GDP) of Iceland in 1999 to that in 2000?
Ensure brevity in your answer.  1.03. What is the ratio of the Value added (% of GDP) in Zambia in 1999 to that in 2000?
Give a very brief answer. 1.08. What is the ratio of the Value added (% of GDP) of Benin in 1999 to that in 2001?
Provide a short and direct response. 1.02. What is the ratio of the Value added (% of GDP) in Iceland in 1999 to that in 2001?
Keep it short and to the point. 0.92. What is the ratio of the Value added (% of GDP) of Zambia in 1999 to that in 2001?
Make the answer very short. 1.12. What is the ratio of the Value added (% of GDP) in Sub-Saharan Africa (all income levels) in 1999 to that in 2002?
Your answer should be compact. 0.98. What is the ratio of the Value added (% of GDP) in Benin in 1999 to that in 2002?
Offer a terse response. 1.01. What is the ratio of the Value added (% of GDP) of Iceland in 1999 to that in 2002?
Ensure brevity in your answer.  1.06. What is the ratio of the Value added (% of GDP) in Zambia in 1999 to that in 2002?
Provide a short and direct response. 1.07. What is the ratio of the Value added (% of GDP) of Sub-Saharan Africa (all income levels) in 1999 to that in 2003?
Your answer should be very brief. 1. What is the ratio of the Value added (% of GDP) in Benin in 1999 to that in 2003?
Offer a very short reply. 1.04. What is the ratio of the Value added (% of GDP) in Iceland in 1999 to that in 2003?
Give a very brief answer. 1.13. What is the ratio of the Value added (% of GDP) of Zambia in 1999 to that in 2003?
Keep it short and to the point. 1.02. What is the ratio of the Value added (% of GDP) in Sub-Saharan Africa (all income levels) in 1999 to that in 2004?
Give a very brief answer. 1.02. What is the ratio of the Value added (% of GDP) in Benin in 1999 to that in 2004?
Keep it short and to the point. 1.11. What is the ratio of the Value added (% of GDP) in Iceland in 1999 to that in 2004?
Give a very brief answer. 1.15. What is the ratio of the Value added (% of GDP) of Zambia in 1999 to that in 2004?
Provide a short and direct response. 1.03. What is the ratio of the Value added (% of GDP) of Sub-Saharan Africa (all income levels) in 2000 to that in 2001?
Provide a short and direct response. 0.99. What is the ratio of the Value added (% of GDP) in Benin in 2000 to that in 2001?
Make the answer very short. 1.01. What is the ratio of the Value added (% of GDP) in Iceland in 2000 to that in 2001?
Provide a short and direct response. 0.89. What is the ratio of the Value added (% of GDP) of Zambia in 2000 to that in 2001?
Give a very brief answer. 1.04. What is the ratio of the Value added (% of GDP) of Sub-Saharan Africa (all income levels) in 2000 to that in 2002?
Keep it short and to the point. 0.98. What is the ratio of the Value added (% of GDP) in Benin in 2000 to that in 2002?
Ensure brevity in your answer.  1.01. What is the ratio of the Value added (% of GDP) of Iceland in 2000 to that in 2002?
Your response must be concise. 1.02. What is the ratio of the Value added (% of GDP) in Zambia in 2000 to that in 2002?
Offer a terse response. 0.99. What is the ratio of the Value added (% of GDP) of Sub-Saharan Africa (all income levels) in 2000 to that in 2003?
Your answer should be compact. 1. What is the ratio of the Value added (% of GDP) in Benin in 2000 to that in 2003?
Your response must be concise. 1.03. What is the ratio of the Value added (% of GDP) in Iceland in 2000 to that in 2003?
Provide a short and direct response. 1.1. What is the ratio of the Value added (% of GDP) in Zambia in 2000 to that in 2003?
Give a very brief answer. 0.94. What is the ratio of the Value added (% of GDP) in Benin in 2000 to that in 2004?
Make the answer very short. 1.1. What is the ratio of the Value added (% of GDP) of Iceland in 2000 to that in 2004?
Provide a short and direct response. 1.12. What is the ratio of the Value added (% of GDP) of Zambia in 2000 to that in 2004?
Your response must be concise. 0.96. What is the ratio of the Value added (% of GDP) of Sub-Saharan Africa (all income levels) in 2001 to that in 2002?
Provide a short and direct response. 0.99. What is the ratio of the Value added (% of GDP) of Iceland in 2001 to that in 2002?
Provide a short and direct response. 1.15. What is the ratio of the Value added (% of GDP) of Zambia in 2001 to that in 2002?
Keep it short and to the point. 0.96. What is the ratio of the Value added (% of GDP) in Sub-Saharan Africa (all income levels) in 2001 to that in 2003?
Provide a succinct answer. 1.01. What is the ratio of the Value added (% of GDP) of Benin in 2001 to that in 2003?
Your response must be concise. 1.02. What is the ratio of the Value added (% of GDP) of Iceland in 2001 to that in 2003?
Offer a very short reply. 1.23. What is the ratio of the Value added (% of GDP) of Zambia in 2001 to that in 2003?
Your response must be concise. 0.91. What is the ratio of the Value added (% of GDP) in Sub-Saharan Africa (all income levels) in 2001 to that in 2004?
Offer a very short reply. 1.03. What is the ratio of the Value added (% of GDP) in Benin in 2001 to that in 2004?
Give a very brief answer. 1.09. What is the ratio of the Value added (% of GDP) in Iceland in 2001 to that in 2004?
Your answer should be compact. 1.25. What is the ratio of the Value added (% of GDP) in Zambia in 2001 to that in 2004?
Your answer should be very brief. 0.92. What is the ratio of the Value added (% of GDP) of Sub-Saharan Africa (all income levels) in 2002 to that in 2003?
Provide a short and direct response. 1.02. What is the ratio of the Value added (% of GDP) of Benin in 2002 to that in 2003?
Offer a very short reply. 1.03. What is the ratio of the Value added (% of GDP) of Iceland in 2002 to that in 2003?
Offer a very short reply. 1.07. What is the ratio of the Value added (% of GDP) of Sub-Saharan Africa (all income levels) in 2002 to that in 2004?
Your answer should be compact. 1.04. What is the ratio of the Value added (% of GDP) in Benin in 2002 to that in 2004?
Provide a succinct answer. 1.1. What is the ratio of the Value added (% of GDP) in Iceland in 2002 to that in 2004?
Provide a short and direct response. 1.09. What is the ratio of the Value added (% of GDP) in Zambia in 2002 to that in 2004?
Your answer should be compact. 0.96. What is the ratio of the Value added (% of GDP) of Sub-Saharan Africa (all income levels) in 2003 to that in 2004?
Your response must be concise. 1.02. What is the ratio of the Value added (% of GDP) of Benin in 2003 to that in 2004?
Keep it short and to the point. 1.07. What is the ratio of the Value added (% of GDP) in Iceland in 2003 to that in 2004?
Make the answer very short. 1.02. What is the ratio of the Value added (% of GDP) of Zambia in 2003 to that in 2004?
Ensure brevity in your answer.  1.02. What is the difference between the highest and the second highest Value added (% of GDP) of Sub-Saharan Africa (all income levels)?
Your answer should be compact. 0.21. What is the difference between the highest and the second highest Value added (% of GDP) in Benin?
Your answer should be very brief. 0.18. What is the difference between the highest and the second highest Value added (% of GDP) in Iceland?
Your answer should be compact. 0.28. What is the difference between the highest and the second highest Value added (% of GDP) of Zambia?
Your answer should be very brief. 0.71. What is the difference between the highest and the lowest Value added (% of GDP) of Sub-Saharan Africa (all income levels)?
Your response must be concise. 0.8. What is the difference between the highest and the lowest Value added (% of GDP) of Benin?
Your answer should be compact. 15.87. What is the difference between the highest and the lowest Value added (% of GDP) in Iceland?
Your response must be concise. 3.38. What is the difference between the highest and the lowest Value added (% of GDP) of Zambia?
Keep it short and to the point. 1.92. 